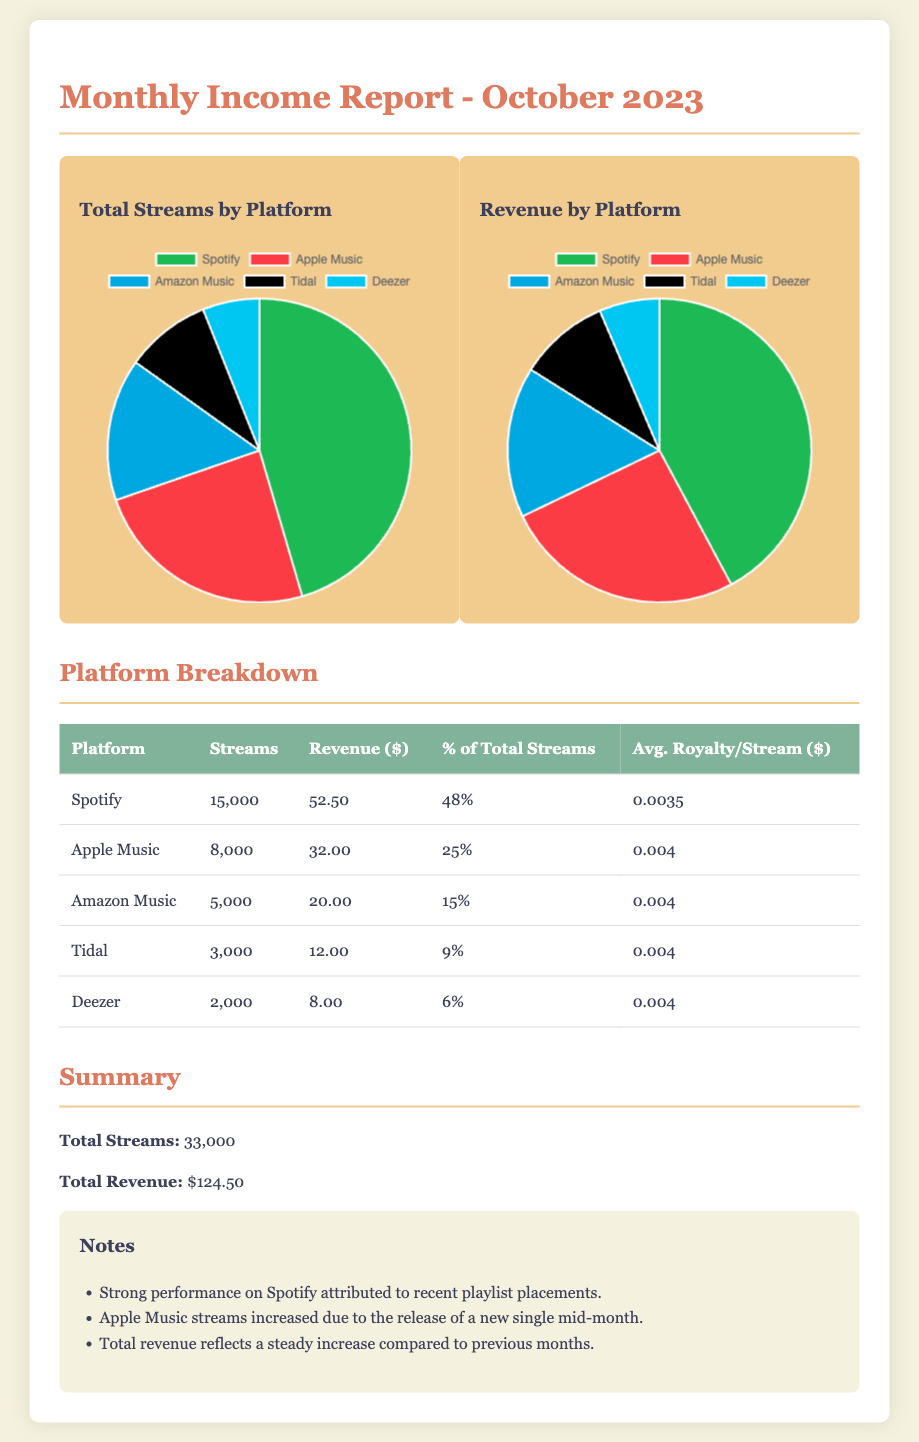What is the total number of streams? The total number of streams is provided in the summary section of the document.
Answer: 33,000 What revenue did Spotify generate? The revenue generated by Spotify is listed in the platform breakdown table.
Answer: 52.50 Which platform has the highest percentage of total streams? The platform with the highest percentage of total streams is indicated in the table.
Answer: Spotify How many streams did Deezer have? The number of streams for Deezer is detailed in the platform breakdown.
Answer: 2,000 What percentage of the total streams did Apple Music contribute? The contribution of Apple Music to the total streams is shown in the percentage column of the table.
Answer: 25% What is the average royalty per stream on Amazon Music? The average royalty per stream for Amazon Music is mentioned in the breakdown table.
Answer: 0.004 What is the total revenue from all platforms? The total revenue is calculated by summing the revenue amounts from each platform, as presented in the summary.
Answer: 124.50 What percentage of revenue did Tidal account for? The percentage of revenue from Tidal is listed in the revenue breakdown table.
Answer: 9% What did the note mention about Apple Music? The notes provide insights into performance and trends related to Apple Music.
Answer: Streams increased due to the release of a new single mid-month 